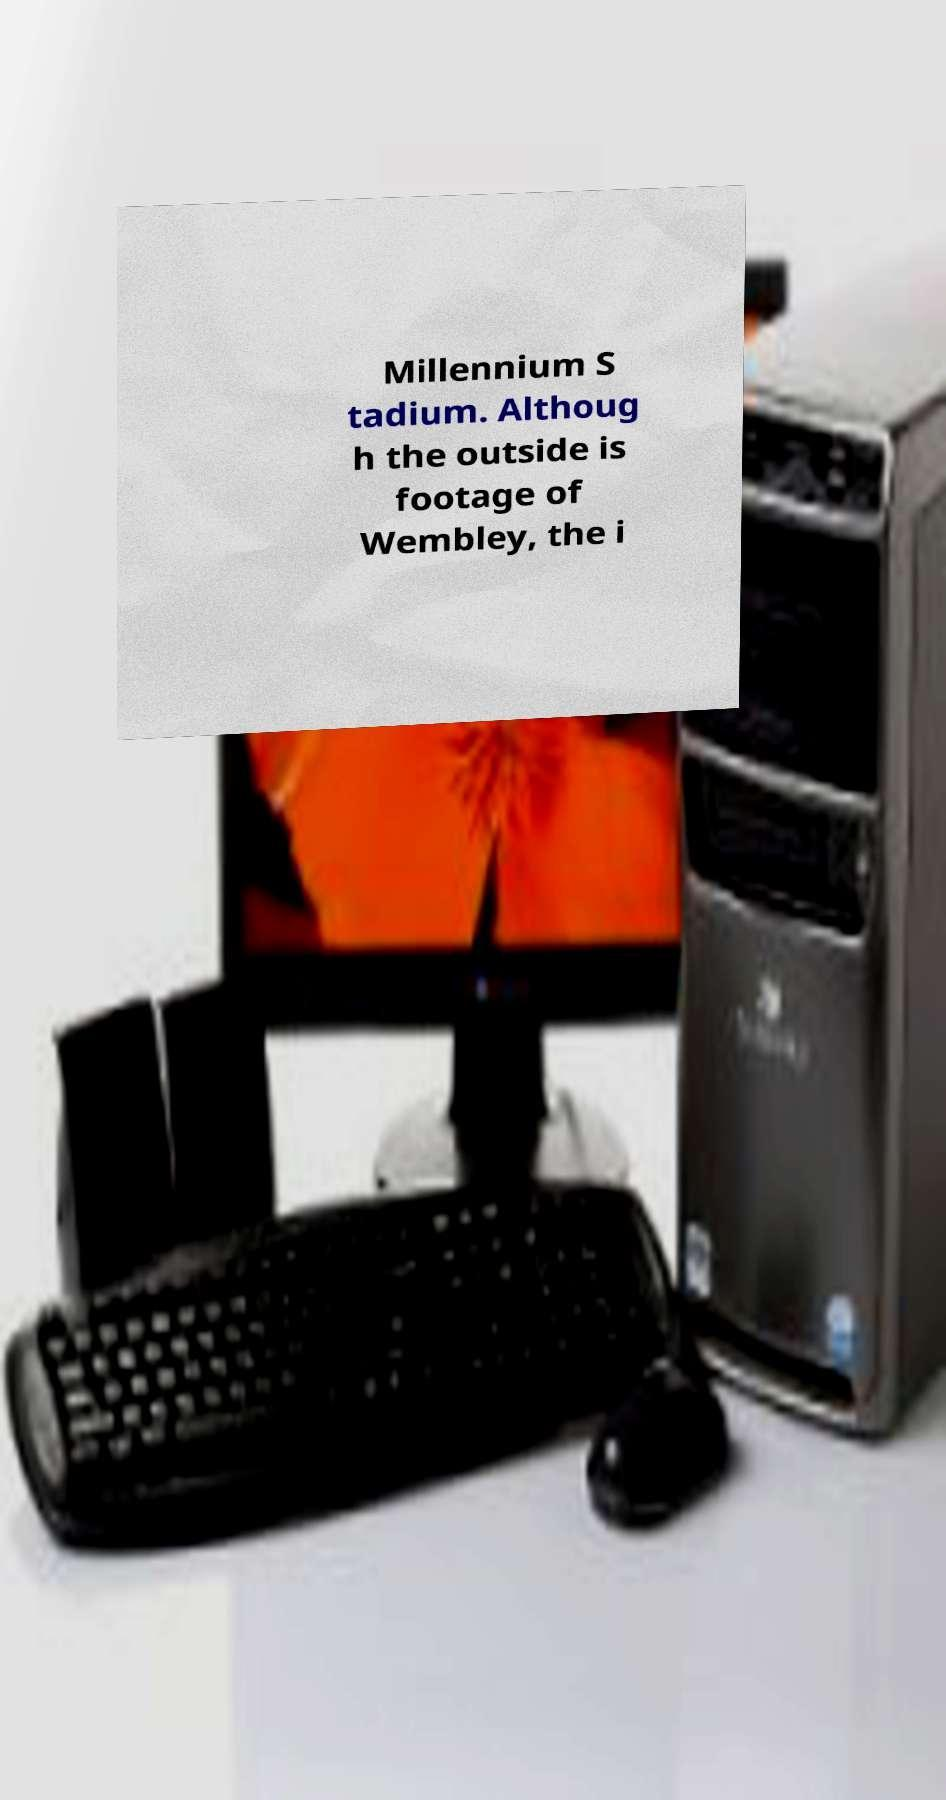There's text embedded in this image that I need extracted. Can you transcribe it verbatim? Millennium S tadium. Althoug h the outside is footage of Wembley, the i 